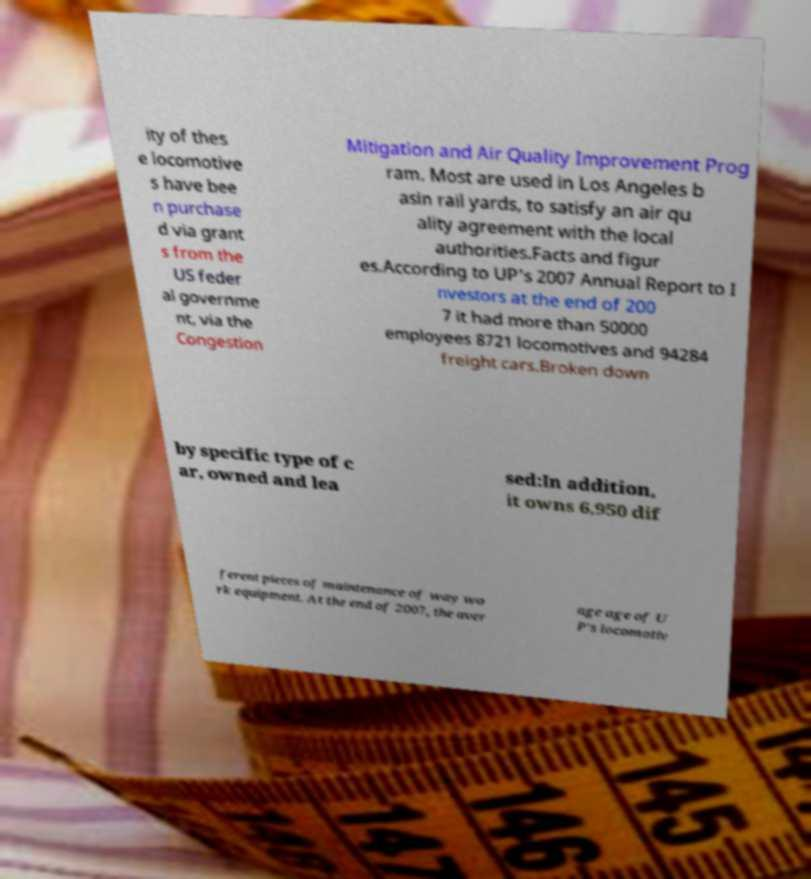Please identify and transcribe the text found in this image. ity of thes e locomotive s have bee n purchase d via grant s from the US feder al governme nt, via the Congestion Mitigation and Air Quality Improvement Prog ram. Most are used in Los Angeles b asin rail yards, to satisfy an air qu ality agreement with the local authorities.Facts and figur es.According to UP's 2007 Annual Report to I nvestors at the end of 200 7 it had more than 50000 employees 8721 locomotives and 94284 freight cars.Broken down by specific type of c ar, owned and lea sed:In addition, it owns 6,950 dif ferent pieces of maintenance of way wo rk equipment. At the end of 2007, the aver age age of U P's locomotiv 